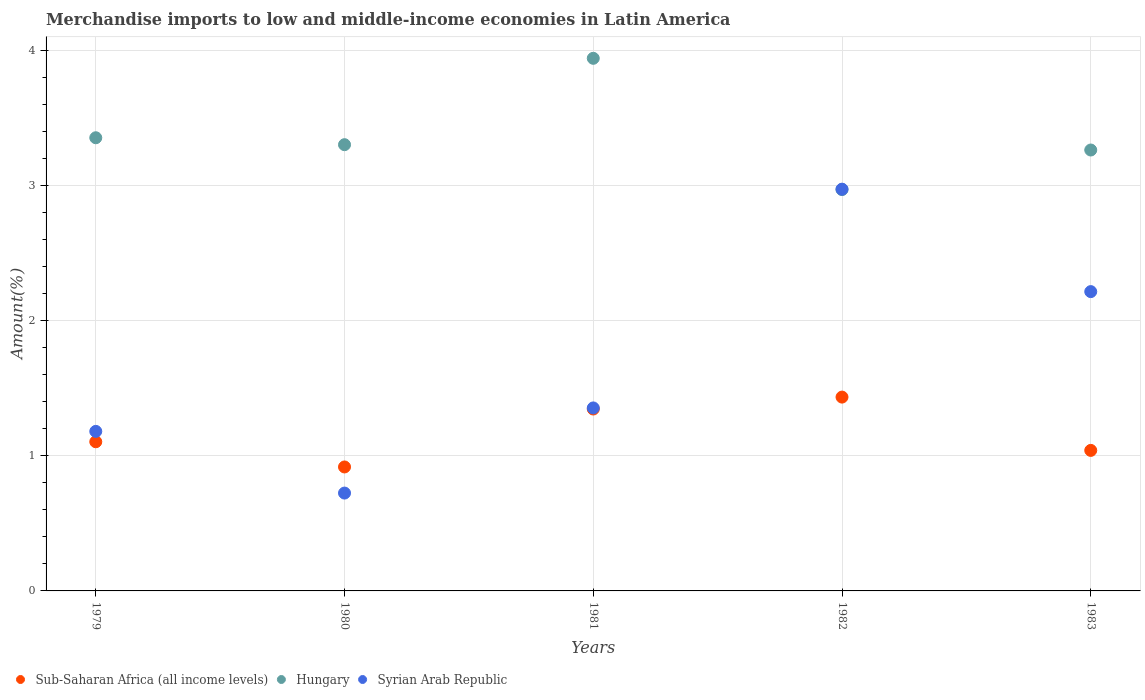How many different coloured dotlines are there?
Provide a succinct answer. 3. Is the number of dotlines equal to the number of legend labels?
Offer a very short reply. Yes. What is the percentage of amount earned from merchandise imports in Sub-Saharan Africa (all income levels) in 1980?
Provide a short and direct response. 0.92. Across all years, what is the maximum percentage of amount earned from merchandise imports in Sub-Saharan Africa (all income levels)?
Give a very brief answer. 1.44. Across all years, what is the minimum percentage of amount earned from merchandise imports in Syrian Arab Republic?
Provide a succinct answer. 0.72. In which year was the percentage of amount earned from merchandise imports in Hungary minimum?
Give a very brief answer. 1982. What is the total percentage of amount earned from merchandise imports in Hungary in the graph?
Provide a succinct answer. 16.84. What is the difference between the percentage of amount earned from merchandise imports in Syrian Arab Republic in 1979 and that in 1981?
Your answer should be compact. -0.17. What is the difference between the percentage of amount earned from merchandise imports in Syrian Arab Republic in 1979 and the percentage of amount earned from merchandise imports in Hungary in 1981?
Make the answer very short. -2.76. What is the average percentage of amount earned from merchandise imports in Sub-Saharan Africa (all income levels) per year?
Give a very brief answer. 1.17. In the year 1982, what is the difference between the percentage of amount earned from merchandise imports in Syrian Arab Republic and percentage of amount earned from merchandise imports in Sub-Saharan Africa (all income levels)?
Offer a very short reply. 1.54. In how many years, is the percentage of amount earned from merchandise imports in Sub-Saharan Africa (all income levels) greater than 0.2 %?
Ensure brevity in your answer.  5. What is the ratio of the percentage of amount earned from merchandise imports in Sub-Saharan Africa (all income levels) in 1979 to that in 1980?
Offer a very short reply. 1.2. What is the difference between the highest and the second highest percentage of amount earned from merchandise imports in Hungary?
Your answer should be very brief. 0.59. What is the difference between the highest and the lowest percentage of amount earned from merchandise imports in Sub-Saharan Africa (all income levels)?
Offer a terse response. 0.52. In how many years, is the percentage of amount earned from merchandise imports in Syrian Arab Republic greater than the average percentage of amount earned from merchandise imports in Syrian Arab Republic taken over all years?
Your answer should be very brief. 2. Is the sum of the percentage of amount earned from merchandise imports in Sub-Saharan Africa (all income levels) in 1982 and 1983 greater than the maximum percentage of amount earned from merchandise imports in Hungary across all years?
Keep it short and to the point. No. Is the percentage of amount earned from merchandise imports in Syrian Arab Republic strictly less than the percentage of amount earned from merchandise imports in Hungary over the years?
Your answer should be compact. No. What is the difference between two consecutive major ticks on the Y-axis?
Ensure brevity in your answer.  1. Are the values on the major ticks of Y-axis written in scientific E-notation?
Your answer should be compact. No. Does the graph contain grids?
Ensure brevity in your answer.  Yes. How are the legend labels stacked?
Your answer should be very brief. Horizontal. What is the title of the graph?
Your answer should be very brief. Merchandise imports to low and middle-income economies in Latin America. What is the label or title of the X-axis?
Offer a very short reply. Years. What is the label or title of the Y-axis?
Provide a short and direct response. Amount(%). What is the Amount(%) in Sub-Saharan Africa (all income levels) in 1979?
Your answer should be compact. 1.1. What is the Amount(%) in Hungary in 1979?
Your answer should be very brief. 3.36. What is the Amount(%) in Syrian Arab Republic in 1979?
Give a very brief answer. 1.18. What is the Amount(%) of Sub-Saharan Africa (all income levels) in 1980?
Your answer should be compact. 0.92. What is the Amount(%) of Hungary in 1980?
Offer a very short reply. 3.3. What is the Amount(%) of Syrian Arab Republic in 1980?
Your answer should be very brief. 0.72. What is the Amount(%) of Sub-Saharan Africa (all income levels) in 1981?
Provide a succinct answer. 1.35. What is the Amount(%) in Hungary in 1981?
Your answer should be compact. 3.94. What is the Amount(%) in Syrian Arab Republic in 1981?
Your answer should be very brief. 1.35. What is the Amount(%) of Sub-Saharan Africa (all income levels) in 1982?
Your answer should be compact. 1.44. What is the Amount(%) of Hungary in 1982?
Keep it short and to the point. 2.97. What is the Amount(%) of Syrian Arab Republic in 1982?
Your answer should be very brief. 2.97. What is the Amount(%) of Sub-Saharan Africa (all income levels) in 1983?
Give a very brief answer. 1.04. What is the Amount(%) of Hungary in 1983?
Give a very brief answer. 3.26. What is the Amount(%) of Syrian Arab Republic in 1983?
Give a very brief answer. 2.22. Across all years, what is the maximum Amount(%) of Sub-Saharan Africa (all income levels)?
Offer a very short reply. 1.44. Across all years, what is the maximum Amount(%) in Hungary?
Your answer should be very brief. 3.94. Across all years, what is the maximum Amount(%) of Syrian Arab Republic?
Provide a short and direct response. 2.97. Across all years, what is the minimum Amount(%) in Sub-Saharan Africa (all income levels)?
Ensure brevity in your answer.  0.92. Across all years, what is the minimum Amount(%) in Hungary?
Keep it short and to the point. 2.97. Across all years, what is the minimum Amount(%) of Syrian Arab Republic?
Your response must be concise. 0.72. What is the total Amount(%) in Sub-Saharan Africa (all income levels) in the graph?
Offer a very short reply. 5.84. What is the total Amount(%) of Hungary in the graph?
Keep it short and to the point. 16.84. What is the total Amount(%) of Syrian Arab Republic in the graph?
Your response must be concise. 8.45. What is the difference between the Amount(%) of Sub-Saharan Africa (all income levels) in 1979 and that in 1980?
Your answer should be very brief. 0.19. What is the difference between the Amount(%) of Hungary in 1979 and that in 1980?
Provide a short and direct response. 0.05. What is the difference between the Amount(%) of Syrian Arab Republic in 1979 and that in 1980?
Ensure brevity in your answer.  0.46. What is the difference between the Amount(%) in Sub-Saharan Africa (all income levels) in 1979 and that in 1981?
Offer a terse response. -0.24. What is the difference between the Amount(%) in Hungary in 1979 and that in 1981?
Your answer should be very brief. -0.59. What is the difference between the Amount(%) of Syrian Arab Republic in 1979 and that in 1981?
Your answer should be compact. -0.17. What is the difference between the Amount(%) of Sub-Saharan Africa (all income levels) in 1979 and that in 1982?
Give a very brief answer. -0.33. What is the difference between the Amount(%) of Hungary in 1979 and that in 1982?
Provide a short and direct response. 0.38. What is the difference between the Amount(%) in Syrian Arab Republic in 1979 and that in 1982?
Ensure brevity in your answer.  -1.79. What is the difference between the Amount(%) of Sub-Saharan Africa (all income levels) in 1979 and that in 1983?
Provide a short and direct response. 0.06. What is the difference between the Amount(%) in Hungary in 1979 and that in 1983?
Your answer should be compact. 0.09. What is the difference between the Amount(%) of Syrian Arab Republic in 1979 and that in 1983?
Your answer should be compact. -1.03. What is the difference between the Amount(%) of Sub-Saharan Africa (all income levels) in 1980 and that in 1981?
Offer a terse response. -0.43. What is the difference between the Amount(%) of Hungary in 1980 and that in 1981?
Keep it short and to the point. -0.64. What is the difference between the Amount(%) of Syrian Arab Republic in 1980 and that in 1981?
Your response must be concise. -0.63. What is the difference between the Amount(%) in Sub-Saharan Africa (all income levels) in 1980 and that in 1982?
Make the answer very short. -0.52. What is the difference between the Amount(%) in Hungary in 1980 and that in 1982?
Your response must be concise. 0.33. What is the difference between the Amount(%) of Syrian Arab Republic in 1980 and that in 1982?
Ensure brevity in your answer.  -2.25. What is the difference between the Amount(%) in Sub-Saharan Africa (all income levels) in 1980 and that in 1983?
Keep it short and to the point. -0.12. What is the difference between the Amount(%) of Hungary in 1980 and that in 1983?
Your response must be concise. 0.04. What is the difference between the Amount(%) of Syrian Arab Republic in 1980 and that in 1983?
Offer a terse response. -1.49. What is the difference between the Amount(%) of Sub-Saharan Africa (all income levels) in 1981 and that in 1982?
Your response must be concise. -0.09. What is the difference between the Amount(%) in Syrian Arab Republic in 1981 and that in 1982?
Offer a terse response. -1.62. What is the difference between the Amount(%) in Sub-Saharan Africa (all income levels) in 1981 and that in 1983?
Offer a very short reply. 0.31. What is the difference between the Amount(%) of Hungary in 1981 and that in 1983?
Your answer should be very brief. 0.68. What is the difference between the Amount(%) of Syrian Arab Republic in 1981 and that in 1983?
Offer a terse response. -0.86. What is the difference between the Amount(%) in Sub-Saharan Africa (all income levels) in 1982 and that in 1983?
Offer a terse response. 0.39. What is the difference between the Amount(%) of Hungary in 1982 and that in 1983?
Give a very brief answer. -0.29. What is the difference between the Amount(%) of Syrian Arab Republic in 1982 and that in 1983?
Make the answer very short. 0.76. What is the difference between the Amount(%) of Sub-Saharan Africa (all income levels) in 1979 and the Amount(%) of Hungary in 1980?
Provide a short and direct response. -2.2. What is the difference between the Amount(%) of Sub-Saharan Africa (all income levels) in 1979 and the Amount(%) of Syrian Arab Republic in 1980?
Provide a short and direct response. 0.38. What is the difference between the Amount(%) of Hungary in 1979 and the Amount(%) of Syrian Arab Republic in 1980?
Provide a short and direct response. 2.63. What is the difference between the Amount(%) of Sub-Saharan Africa (all income levels) in 1979 and the Amount(%) of Hungary in 1981?
Your response must be concise. -2.84. What is the difference between the Amount(%) of Sub-Saharan Africa (all income levels) in 1979 and the Amount(%) of Syrian Arab Republic in 1981?
Give a very brief answer. -0.25. What is the difference between the Amount(%) of Hungary in 1979 and the Amount(%) of Syrian Arab Republic in 1981?
Make the answer very short. 2. What is the difference between the Amount(%) of Sub-Saharan Africa (all income levels) in 1979 and the Amount(%) of Hungary in 1982?
Make the answer very short. -1.87. What is the difference between the Amount(%) of Sub-Saharan Africa (all income levels) in 1979 and the Amount(%) of Syrian Arab Republic in 1982?
Keep it short and to the point. -1.87. What is the difference between the Amount(%) of Hungary in 1979 and the Amount(%) of Syrian Arab Republic in 1982?
Make the answer very short. 0.38. What is the difference between the Amount(%) of Sub-Saharan Africa (all income levels) in 1979 and the Amount(%) of Hungary in 1983?
Your response must be concise. -2.16. What is the difference between the Amount(%) in Sub-Saharan Africa (all income levels) in 1979 and the Amount(%) in Syrian Arab Republic in 1983?
Offer a terse response. -1.11. What is the difference between the Amount(%) in Hungary in 1979 and the Amount(%) in Syrian Arab Republic in 1983?
Offer a very short reply. 1.14. What is the difference between the Amount(%) in Sub-Saharan Africa (all income levels) in 1980 and the Amount(%) in Hungary in 1981?
Your answer should be compact. -3.03. What is the difference between the Amount(%) of Sub-Saharan Africa (all income levels) in 1980 and the Amount(%) of Syrian Arab Republic in 1981?
Keep it short and to the point. -0.44. What is the difference between the Amount(%) in Hungary in 1980 and the Amount(%) in Syrian Arab Republic in 1981?
Your response must be concise. 1.95. What is the difference between the Amount(%) of Sub-Saharan Africa (all income levels) in 1980 and the Amount(%) of Hungary in 1982?
Offer a terse response. -2.05. What is the difference between the Amount(%) of Sub-Saharan Africa (all income levels) in 1980 and the Amount(%) of Syrian Arab Republic in 1982?
Provide a short and direct response. -2.06. What is the difference between the Amount(%) of Hungary in 1980 and the Amount(%) of Syrian Arab Republic in 1982?
Ensure brevity in your answer.  0.33. What is the difference between the Amount(%) in Sub-Saharan Africa (all income levels) in 1980 and the Amount(%) in Hungary in 1983?
Offer a terse response. -2.35. What is the difference between the Amount(%) in Sub-Saharan Africa (all income levels) in 1980 and the Amount(%) in Syrian Arab Republic in 1983?
Ensure brevity in your answer.  -1.3. What is the difference between the Amount(%) of Hungary in 1980 and the Amount(%) of Syrian Arab Republic in 1983?
Your response must be concise. 1.09. What is the difference between the Amount(%) of Sub-Saharan Africa (all income levels) in 1981 and the Amount(%) of Hungary in 1982?
Offer a very short reply. -1.62. What is the difference between the Amount(%) in Sub-Saharan Africa (all income levels) in 1981 and the Amount(%) in Syrian Arab Republic in 1982?
Your answer should be very brief. -1.63. What is the difference between the Amount(%) of Sub-Saharan Africa (all income levels) in 1981 and the Amount(%) of Hungary in 1983?
Offer a very short reply. -1.92. What is the difference between the Amount(%) of Sub-Saharan Africa (all income levels) in 1981 and the Amount(%) of Syrian Arab Republic in 1983?
Your answer should be compact. -0.87. What is the difference between the Amount(%) in Hungary in 1981 and the Amount(%) in Syrian Arab Republic in 1983?
Offer a very short reply. 1.73. What is the difference between the Amount(%) of Sub-Saharan Africa (all income levels) in 1982 and the Amount(%) of Hungary in 1983?
Offer a very short reply. -1.83. What is the difference between the Amount(%) of Sub-Saharan Africa (all income levels) in 1982 and the Amount(%) of Syrian Arab Republic in 1983?
Offer a terse response. -0.78. What is the difference between the Amount(%) in Hungary in 1982 and the Amount(%) in Syrian Arab Republic in 1983?
Offer a terse response. 0.76. What is the average Amount(%) in Sub-Saharan Africa (all income levels) per year?
Provide a short and direct response. 1.17. What is the average Amount(%) of Hungary per year?
Ensure brevity in your answer.  3.37. What is the average Amount(%) of Syrian Arab Republic per year?
Make the answer very short. 1.69. In the year 1979, what is the difference between the Amount(%) of Sub-Saharan Africa (all income levels) and Amount(%) of Hungary?
Give a very brief answer. -2.25. In the year 1979, what is the difference between the Amount(%) of Sub-Saharan Africa (all income levels) and Amount(%) of Syrian Arab Republic?
Offer a very short reply. -0.08. In the year 1979, what is the difference between the Amount(%) in Hungary and Amount(%) in Syrian Arab Republic?
Your answer should be compact. 2.17. In the year 1980, what is the difference between the Amount(%) of Sub-Saharan Africa (all income levels) and Amount(%) of Hungary?
Your response must be concise. -2.39. In the year 1980, what is the difference between the Amount(%) of Sub-Saharan Africa (all income levels) and Amount(%) of Syrian Arab Republic?
Keep it short and to the point. 0.19. In the year 1980, what is the difference between the Amount(%) of Hungary and Amount(%) of Syrian Arab Republic?
Give a very brief answer. 2.58. In the year 1981, what is the difference between the Amount(%) in Sub-Saharan Africa (all income levels) and Amount(%) in Hungary?
Provide a short and direct response. -2.6. In the year 1981, what is the difference between the Amount(%) of Sub-Saharan Africa (all income levels) and Amount(%) of Syrian Arab Republic?
Keep it short and to the point. -0.01. In the year 1981, what is the difference between the Amount(%) in Hungary and Amount(%) in Syrian Arab Republic?
Your response must be concise. 2.59. In the year 1982, what is the difference between the Amount(%) of Sub-Saharan Africa (all income levels) and Amount(%) of Hungary?
Offer a terse response. -1.54. In the year 1982, what is the difference between the Amount(%) in Sub-Saharan Africa (all income levels) and Amount(%) in Syrian Arab Republic?
Ensure brevity in your answer.  -1.54. In the year 1982, what is the difference between the Amount(%) in Hungary and Amount(%) in Syrian Arab Republic?
Your answer should be very brief. -0. In the year 1983, what is the difference between the Amount(%) of Sub-Saharan Africa (all income levels) and Amount(%) of Hungary?
Offer a very short reply. -2.22. In the year 1983, what is the difference between the Amount(%) in Sub-Saharan Africa (all income levels) and Amount(%) in Syrian Arab Republic?
Keep it short and to the point. -1.18. In the year 1983, what is the difference between the Amount(%) of Hungary and Amount(%) of Syrian Arab Republic?
Provide a short and direct response. 1.05. What is the ratio of the Amount(%) in Sub-Saharan Africa (all income levels) in 1979 to that in 1980?
Keep it short and to the point. 1.2. What is the ratio of the Amount(%) in Hungary in 1979 to that in 1980?
Your answer should be compact. 1.02. What is the ratio of the Amount(%) in Syrian Arab Republic in 1979 to that in 1980?
Provide a succinct answer. 1.63. What is the ratio of the Amount(%) of Sub-Saharan Africa (all income levels) in 1979 to that in 1981?
Your answer should be compact. 0.82. What is the ratio of the Amount(%) in Hungary in 1979 to that in 1981?
Give a very brief answer. 0.85. What is the ratio of the Amount(%) of Syrian Arab Republic in 1979 to that in 1981?
Offer a terse response. 0.87. What is the ratio of the Amount(%) in Sub-Saharan Africa (all income levels) in 1979 to that in 1982?
Make the answer very short. 0.77. What is the ratio of the Amount(%) in Hungary in 1979 to that in 1982?
Offer a terse response. 1.13. What is the ratio of the Amount(%) of Syrian Arab Republic in 1979 to that in 1982?
Offer a terse response. 0.4. What is the ratio of the Amount(%) of Sub-Saharan Africa (all income levels) in 1979 to that in 1983?
Give a very brief answer. 1.06. What is the ratio of the Amount(%) of Hungary in 1979 to that in 1983?
Your response must be concise. 1.03. What is the ratio of the Amount(%) of Syrian Arab Republic in 1979 to that in 1983?
Keep it short and to the point. 0.53. What is the ratio of the Amount(%) in Sub-Saharan Africa (all income levels) in 1980 to that in 1981?
Offer a very short reply. 0.68. What is the ratio of the Amount(%) in Hungary in 1980 to that in 1981?
Keep it short and to the point. 0.84. What is the ratio of the Amount(%) in Syrian Arab Republic in 1980 to that in 1981?
Offer a terse response. 0.53. What is the ratio of the Amount(%) of Sub-Saharan Africa (all income levels) in 1980 to that in 1982?
Your answer should be very brief. 0.64. What is the ratio of the Amount(%) of Hungary in 1980 to that in 1982?
Make the answer very short. 1.11. What is the ratio of the Amount(%) in Syrian Arab Republic in 1980 to that in 1982?
Your response must be concise. 0.24. What is the ratio of the Amount(%) in Sub-Saharan Africa (all income levels) in 1980 to that in 1983?
Ensure brevity in your answer.  0.88. What is the ratio of the Amount(%) in Hungary in 1980 to that in 1983?
Your response must be concise. 1.01. What is the ratio of the Amount(%) in Syrian Arab Republic in 1980 to that in 1983?
Offer a terse response. 0.33. What is the ratio of the Amount(%) in Sub-Saharan Africa (all income levels) in 1981 to that in 1982?
Make the answer very short. 0.94. What is the ratio of the Amount(%) in Hungary in 1981 to that in 1982?
Give a very brief answer. 1.33. What is the ratio of the Amount(%) in Syrian Arab Republic in 1981 to that in 1982?
Provide a succinct answer. 0.46. What is the ratio of the Amount(%) in Sub-Saharan Africa (all income levels) in 1981 to that in 1983?
Offer a terse response. 1.29. What is the ratio of the Amount(%) in Hungary in 1981 to that in 1983?
Offer a very short reply. 1.21. What is the ratio of the Amount(%) in Syrian Arab Republic in 1981 to that in 1983?
Your response must be concise. 0.61. What is the ratio of the Amount(%) in Sub-Saharan Africa (all income levels) in 1982 to that in 1983?
Offer a terse response. 1.38. What is the ratio of the Amount(%) in Hungary in 1982 to that in 1983?
Provide a succinct answer. 0.91. What is the ratio of the Amount(%) in Syrian Arab Republic in 1982 to that in 1983?
Keep it short and to the point. 1.34. What is the difference between the highest and the second highest Amount(%) in Sub-Saharan Africa (all income levels)?
Keep it short and to the point. 0.09. What is the difference between the highest and the second highest Amount(%) of Hungary?
Offer a terse response. 0.59. What is the difference between the highest and the second highest Amount(%) of Syrian Arab Republic?
Make the answer very short. 0.76. What is the difference between the highest and the lowest Amount(%) in Sub-Saharan Africa (all income levels)?
Your response must be concise. 0.52. What is the difference between the highest and the lowest Amount(%) of Hungary?
Offer a terse response. 0.97. What is the difference between the highest and the lowest Amount(%) of Syrian Arab Republic?
Your response must be concise. 2.25. 